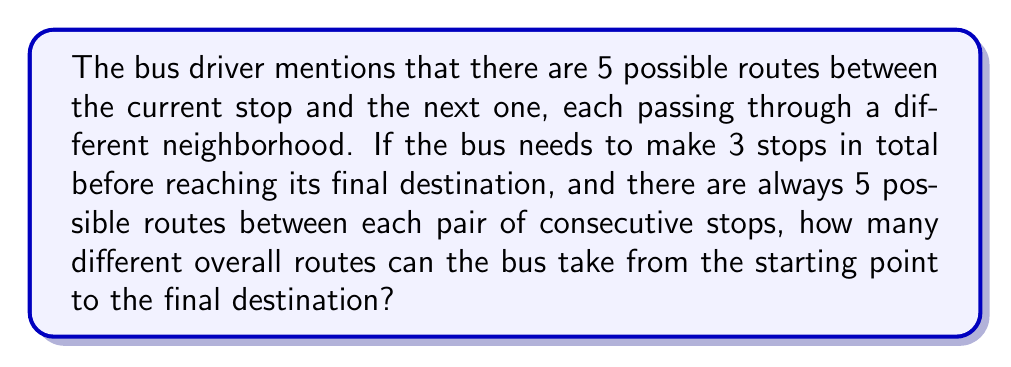What is the answer to this math problem? Let's approach this step-by-step:

1) First, we need to understand what the question is asking. We're looking for the total number of possible routes from the starting point to the final destination, passing through 3 stops in total.

2) Between each pair of stops, there are 5 possible routes. This means we're making 3 independent choices of routes, one after another.

3) This scenario is a perfect application of the multiplication principle in combinatorics. The multiplication principle states that if we have a sequence of $n$ independent choices, where the $i$-th choice has $m_i$ options, then the total number of possible outcomes is the product of all $m_i$.

4) In this case, we have:
   - 5 choices for the route between the first and second stop
   - 5 choices for the route between the second and third stop
   - 5 choices for the route between the third stop and the final destination

5) Therefore, the total number of possible routes is:

   $$ 5 \times 5 \times 5 = 5^3 = 125 $$

6) We can also think of this as a tree diagram where each level of the tree has 5 branches, and we have 3 levels in total. The number of leaves at the bottom of the tree represents the total number of possible routes.

[asy]
size(200);
pair A=(0,0), B=(-4,-2), C=(0,-2), D=(4,-2), E=(-6,-4), F=(-2,-4), G=(2,-4), H=(6,-4);
dot(A); dot(B); dot(C); dot(D); dot(E); dot(F); dot(G); dot(H);
draw(A--B); draw(A--C); draw(A--D);
draw(B--E); draw(B--F);
draw(D--G); draw(D--H);
label("Start",A,N);
label("...",C,S);
label("...",F,S);
label("...",G,S);
[/asy]

This diagram illustrates the first two levels of choices. Each subsequent level would have 5 choices for each node, leading to $5^3 = 125$ total paths at the bottom level.
Answer: $125$ possible routes 